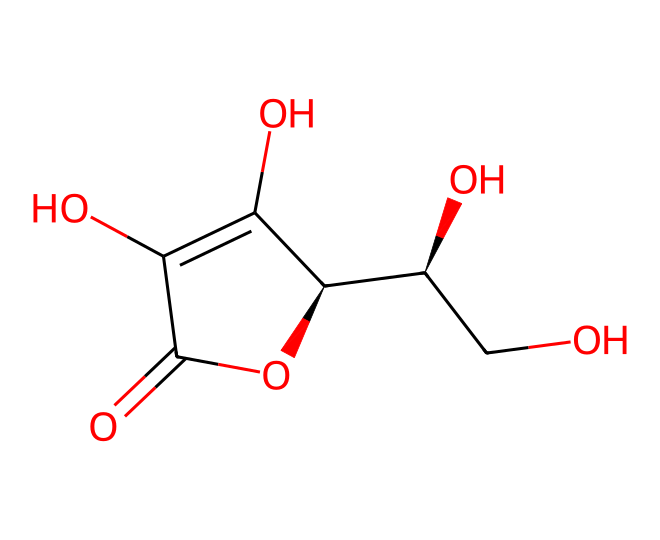What is the molecular formula of ascorbic acid? To determine the molecular formula, count the number of each type of atom in the SMILES string. The structure contains 6 carbon atoms, 8 hydrogen atoms, and 6 oxygen atoms, giving the formula C6H8O6.
Answer: C6H8O6 How many oxygen atoms are in ascorbic acid? By examining the SMILES representation, there are six oxygen atoms present in the structure, as indicated by the 'O' letters in the formula.
Answer: 6 What type of functional groups are present in ascorbic acid? The structure includes hydroxyl (-OH) groups and a carbonyl (C=O) group. The -OH groups are indicated by the -OH components in the structure, and the carbonyl is found at the carbon atom with a double bond to an oxygen.
Answer: hydroxyl and carbonyl How many chiral centers are present in ascorbic acid? By analyzing the structure, there are two chiral centers in ascorbic acid, which can be identified by the presence of carbon atoms bonded to four different substituents.
Answer: 2 What functional role does ascorbic acid serve in the body? Ascorbic acid acts as a dietary antioxidant, which helps to neutralize free radicals in the body, preventing oxidative damage to cells. This role is evident from its chemical structure that allows it to donate electrons.
Answer: antioxidant Which part of the chemical structure contributes to its antioxidant properties? The hydroxyl (-OH) groups are crucial for antioxidant activity because they can donate hydrogen atoms, which neutralize free radicals. The electron-rich nature of these groups allows them to react with reactive oxygen species.
Answer: hydroxyl groups What is the stereochemistry around the chiral centers in ascorbic acid? The chiral centers in ascorbic acid have specific stereochemistry defined by the arrangement of groups around them; in this case, they exhibit R and S configurations based on the Cahn-Ingold-Prelog priority rules. The specific arrangement can be identified by analyzing the attached groups around each chiral carbon.
Answer: R and S configurations 